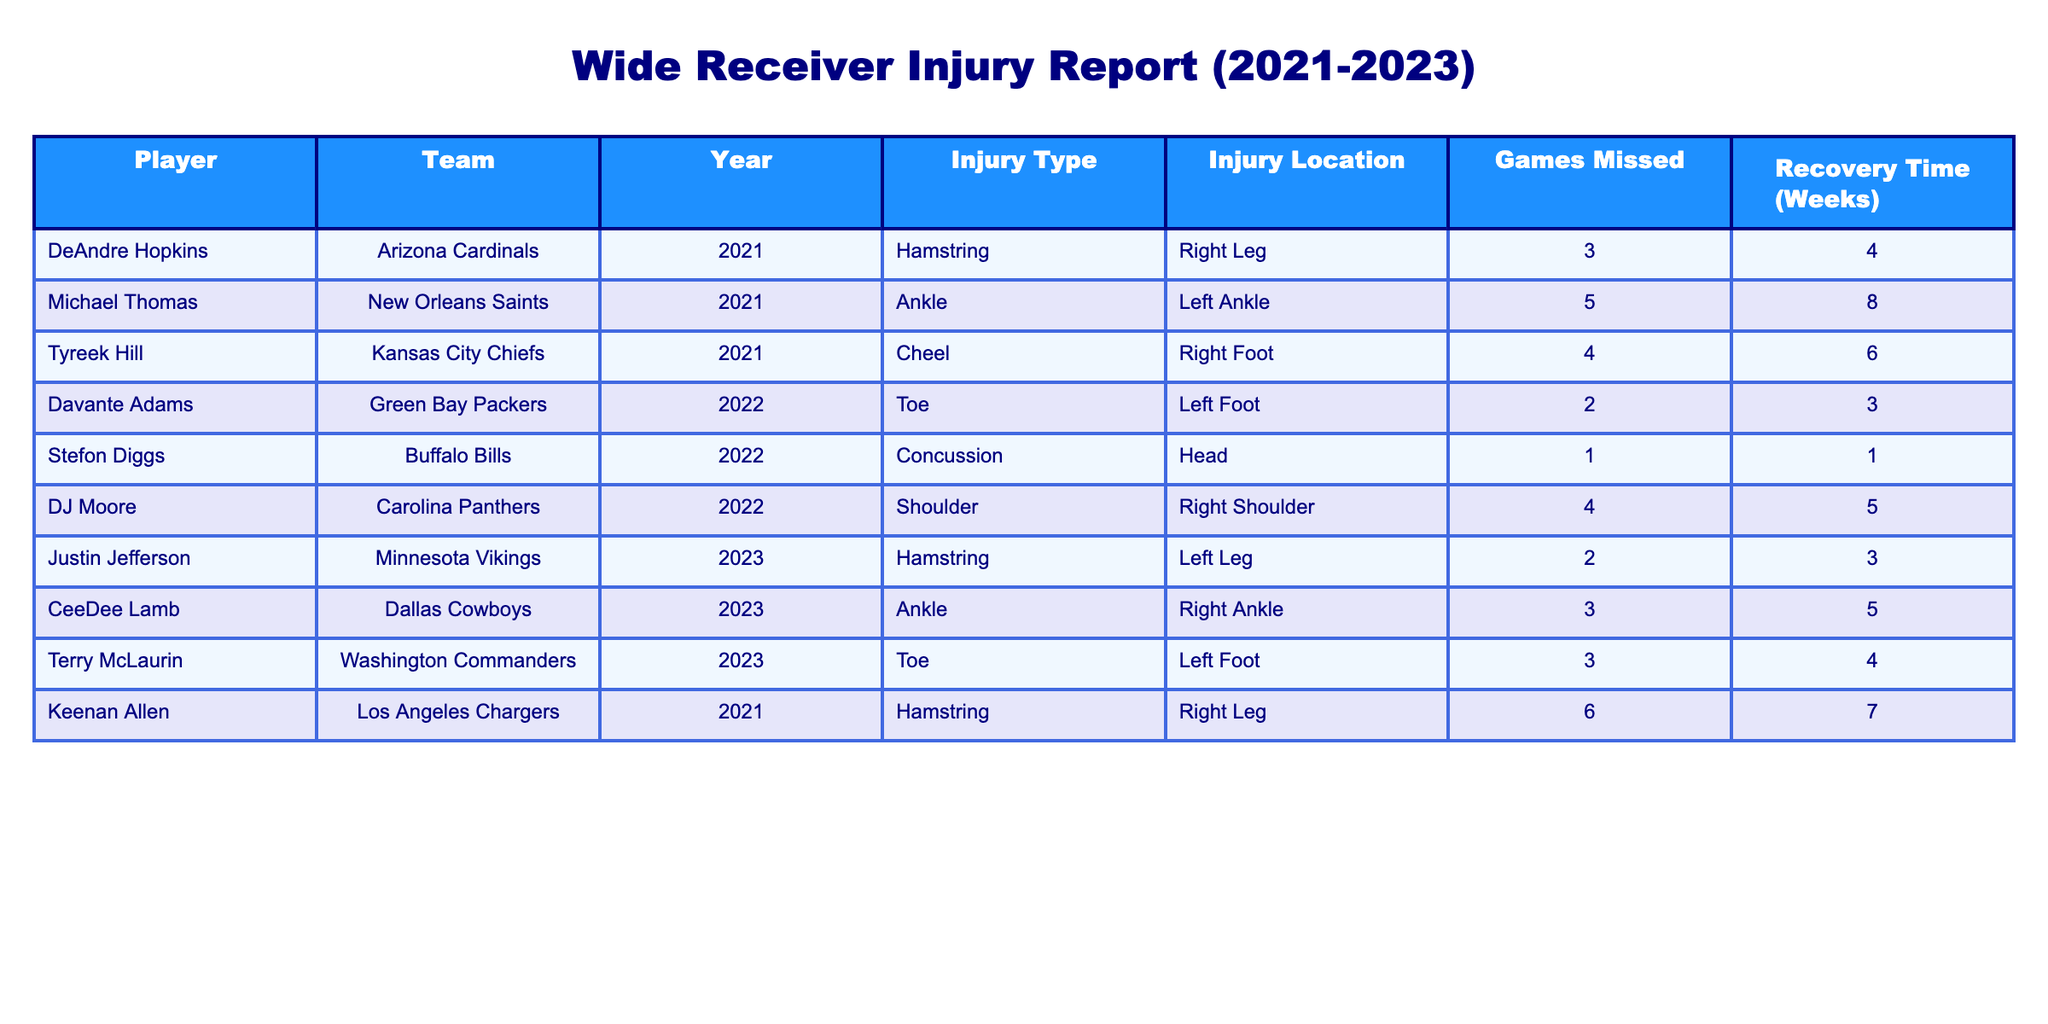What injury did Michael Thomas suffer in 2021? Michael Thomas suffered an ankle injury in 2021, as indicated in the table under the "Injury Type" column for his entry.
Answer: Ankle How many games did DeAndre Hopkins miss due to his injury in 2021? DeAndre Hopkins missed 3 games due to his hamstring injury, which is directly listed in the "Games Missed" column for 2021.
Answer: 3 What is the average recovery time for wide receivers who suffered hamstring injuries over the past three seasons? The players with hamstring injuries are DeAndre Hopkins (4 weeks), Tyreek Hill (6 weeks), and Keenan Allen (7 weeks). The sum of recovery times is 4 + 6 + 7 = 17 weeks. There are 3 players, so the average recovery time is 17/3 = 5.67 weeks.
Answer: 5.67 weeks Did any player miss more than 5 games due to injury in the given table? By checking the "Games Missed" column, the highest value is 6 (for Keenan Allen), indicating that yes, a player did miss more than 5 games.
Answer: Yes Among the injuries listed, which type resulted in the longest recovery time, and how long was it? The injuries and their recovery times are: Hamstring (4, 6, 7 weeks), Ankle (8 weeks), Toe (3, 4 weeks), Concussion (1 week), and Shoulder (5 weeks). The maximum recovery time is 8 weeks for Michael Thomas’s ankle injury.
Answer: Ankle, 8 weeks What percentage of the injuries listed were concussions? There is one documented concussion among a total of 10 injuries in the table. To find the percentage, we use the formula (1/10) * 100 = 10%.
Answer: 10% What can you infer about the trend in the types of injuries among wide receivers between 2021 and 2023? By examining the injury types over the years, we can see various injuries, with no recurring patterns of predominance. Hamstring injuries appear frequently; however, new injury types like concussions emerged, suggesting a continuing risk of diverse injury types relevant to wide receiver play.
Answer: Diverse injury types observed Which player had the shortest recovery time and what was the injury type? Reviewing the table reveals that Stefon Diggs had the shortest recovery time of 1 week due to a concussion, which is clearly stated in the table.
Answer: 1 week, Concussion 